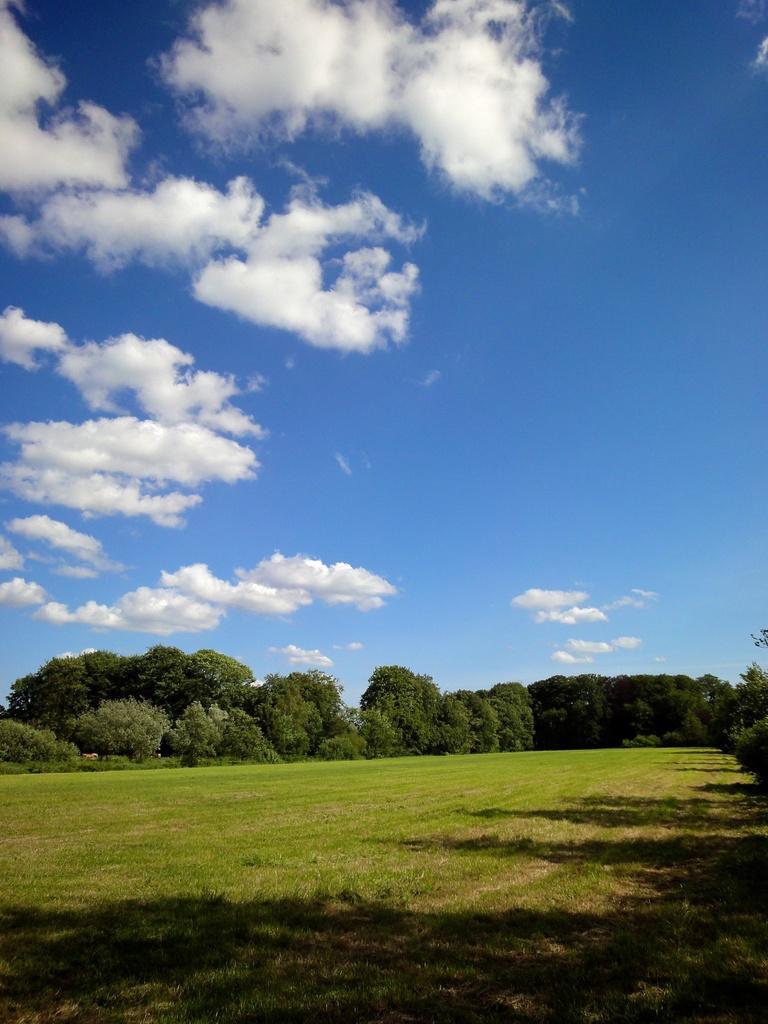Describe this image in one or two sentences. In this picture I can observe some grass on the ground. In the background there are some trees and clouds in the sky. 